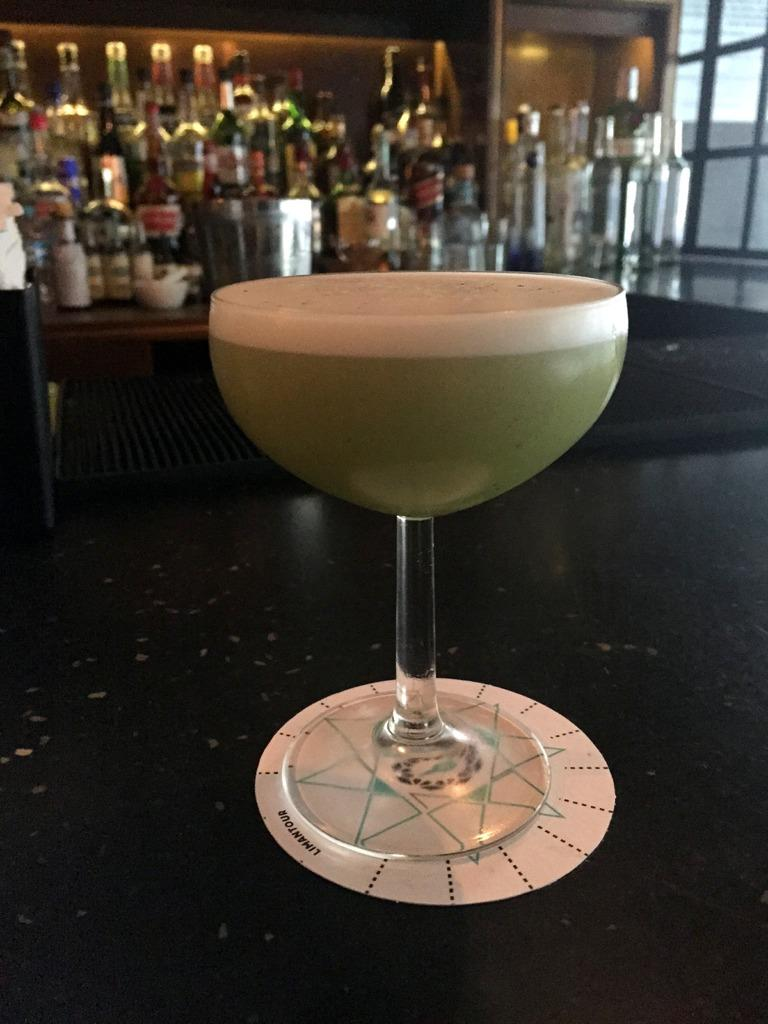What is in the glass that is visible in the image? There is a glass with liquid in the image. What object is associated with the glass? There is an object associated with the glass, but the specific object is not mentioned in the facts. What can be seen in the background of the image? There are wine bottles and other items visible in the background of the image. How many cherries are on the owl in the image? There are no cherries or owls present in the image. What type of pigs can be seen in the background of the image? There are no pigs present in the image. 